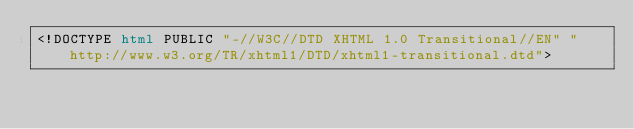Convert code to text. <code><loc_0><loc_0><loc_500><loc_500><_HTML_><!DOCTYPE html PUBLIC "-//W3C//DTD XHTML 1.0 Transitional//EN" "http://www.w3.org/TR/xhtml1/DTD/xhtml1-transitional.dtd"></code> 